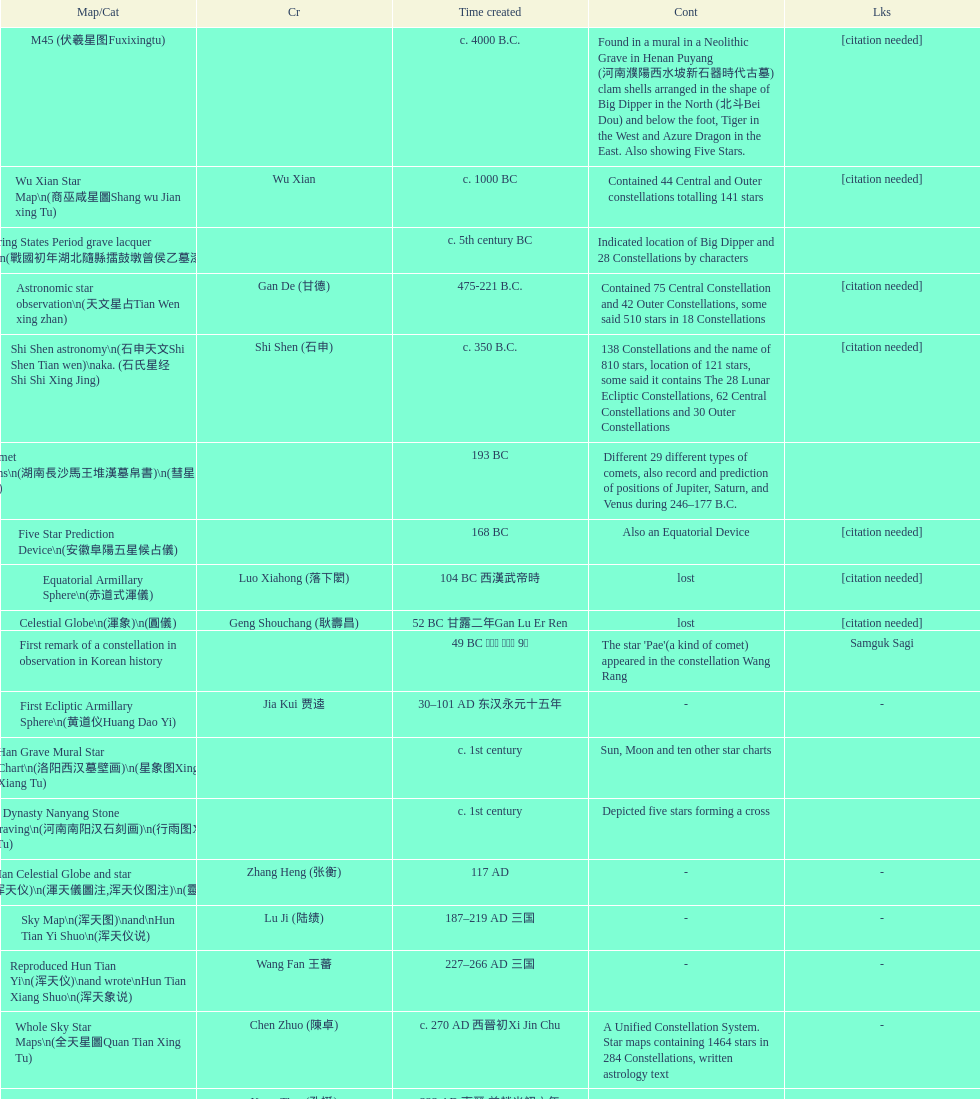What is the difference between the five star prediction device's date of creation and the han comet diagrams' date of creation? 25 years. 